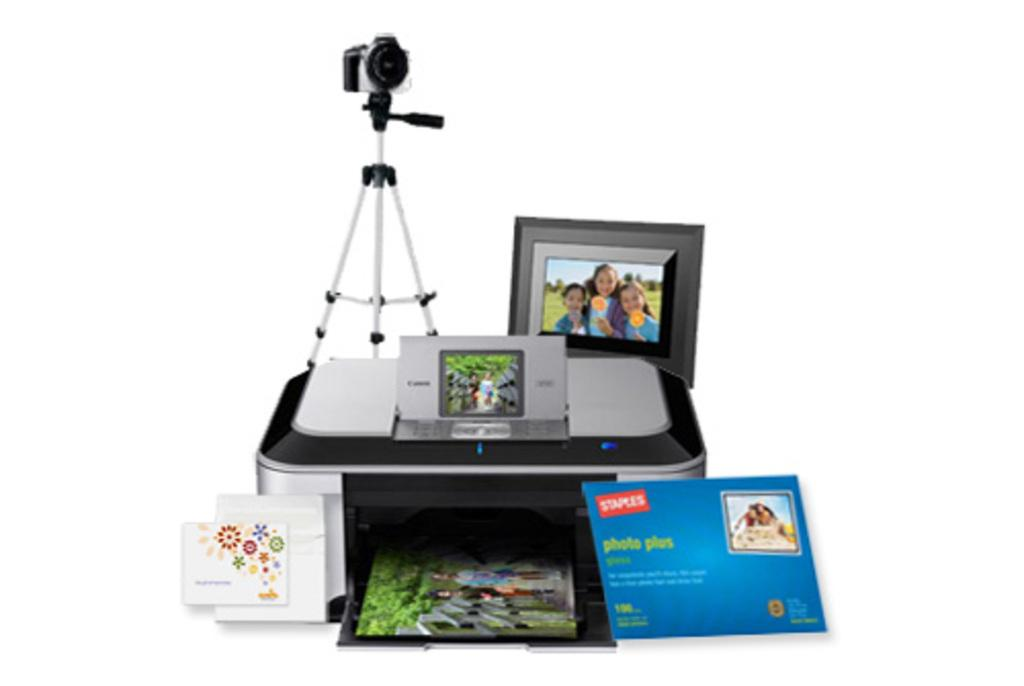What objects in the image are used for displaying or preserving memories? There are photo frames in the image that are used for displaying or preserving memories. What objects in the image are used for communication or documentation? There are cards and a camera in the image that are used for communication or documentation. What object in the image is used for capturing images? There is a camera in the image that is used for capturing images. What object in the image might be used for recording or storing information? There is a device in the image that might be used for recording or storing information. What type of bread is being used to season the dish in the image? There is no bread present in the image, and therefore no bread can be used to season a dish. What type of spark can be seen coming from the device in the image? There is no spark visible in the image, and the device does not appear to be emitting any sparks. 